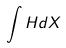Convert formula to latex. <formula><loc_0><loc_0><loc_500><loc_500>\int H d X</formula> 